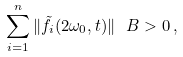<formula> <loc_0><loc_0><loc_500><loc_500>\sum _ { i = 1 } ^ { n } \| \tilde { f } _ { i } ( 2 \omega _ { 0 } , t ) \| _ { \ } B > 0 \, ,</formula> 